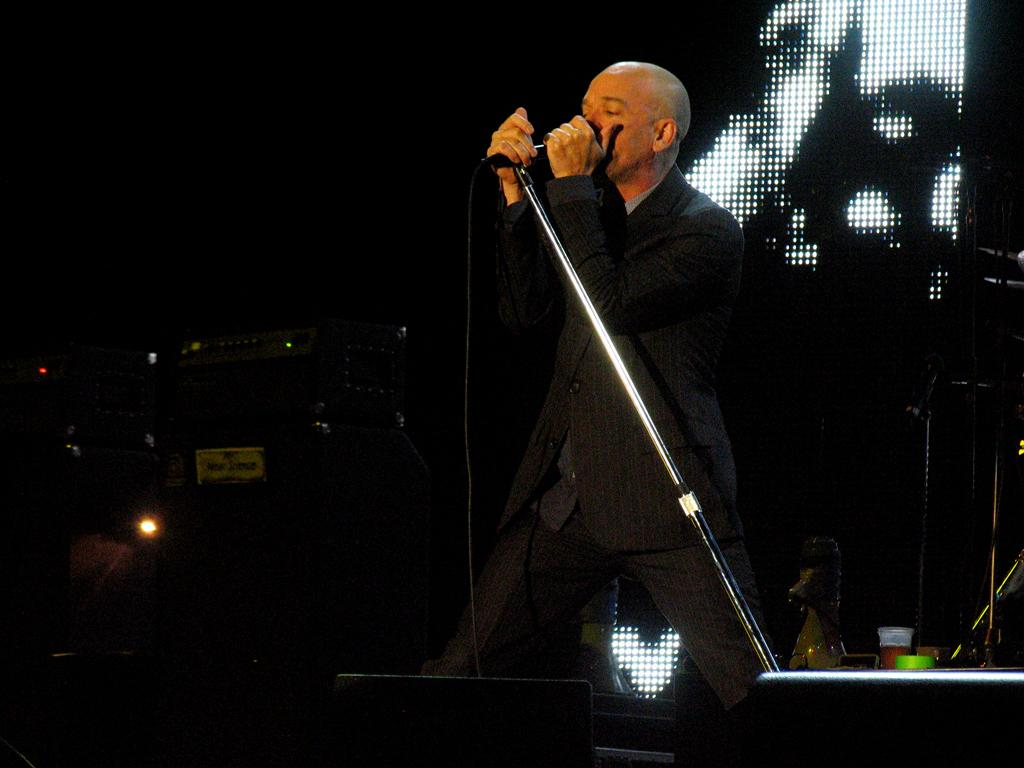What is the main subject of the image? The main subject of the image is a man. What is the man doing in the image? The man is standing in the image. What object is the man holding in the image? The man is holding a mic in the image. How many ants can be seen crawling on the man's arm in the image? There are no ants visible on the man's arm in the image. What type of amusement park ride is present in the image? There is no amusement park ride present in the image; it features a man standing and holding a mic. 